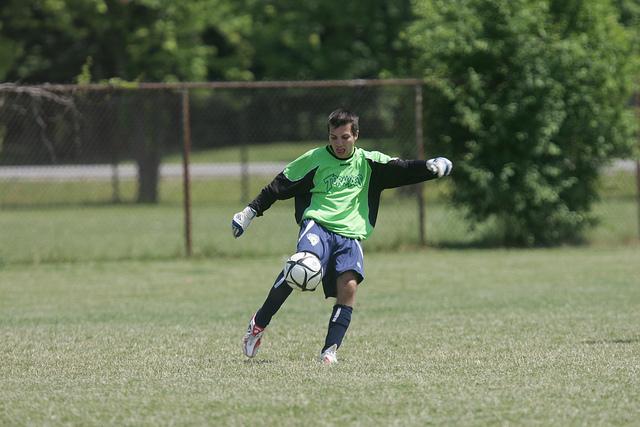Why are there only two men going after the ball?
Be succinct. They are only ones playing. Which kid will kick the ball?
Give a very brief answer. Green shirt. What is the man doing?
Keep it brief. Playing soccer. Does the guy have pants on?
Keep it brief. No. What is she catching?
Answer briefly. Ball. Is the guy good?
Quick response, please. Yes. What game are they playing?
Write a very short answer. Soccer. Which sport is this?
Concise answer only. Soccer. What is the white object flying in the air?
Give a very brief answer. Soccer ball. What product does the company whose symbol is on the player's shirt manufacturer?
Write a very short answer. Adidas. Why are they jumping?
Be succinct. Playing soccer. What color is the goalie wearing?
Quick response, please. Green. Is the sun coming from the left?
Quick response, please. No. Are the playing baseball in a field?
Give a very brief answer. No. Is the guy running?
Write a very short answer. No. 